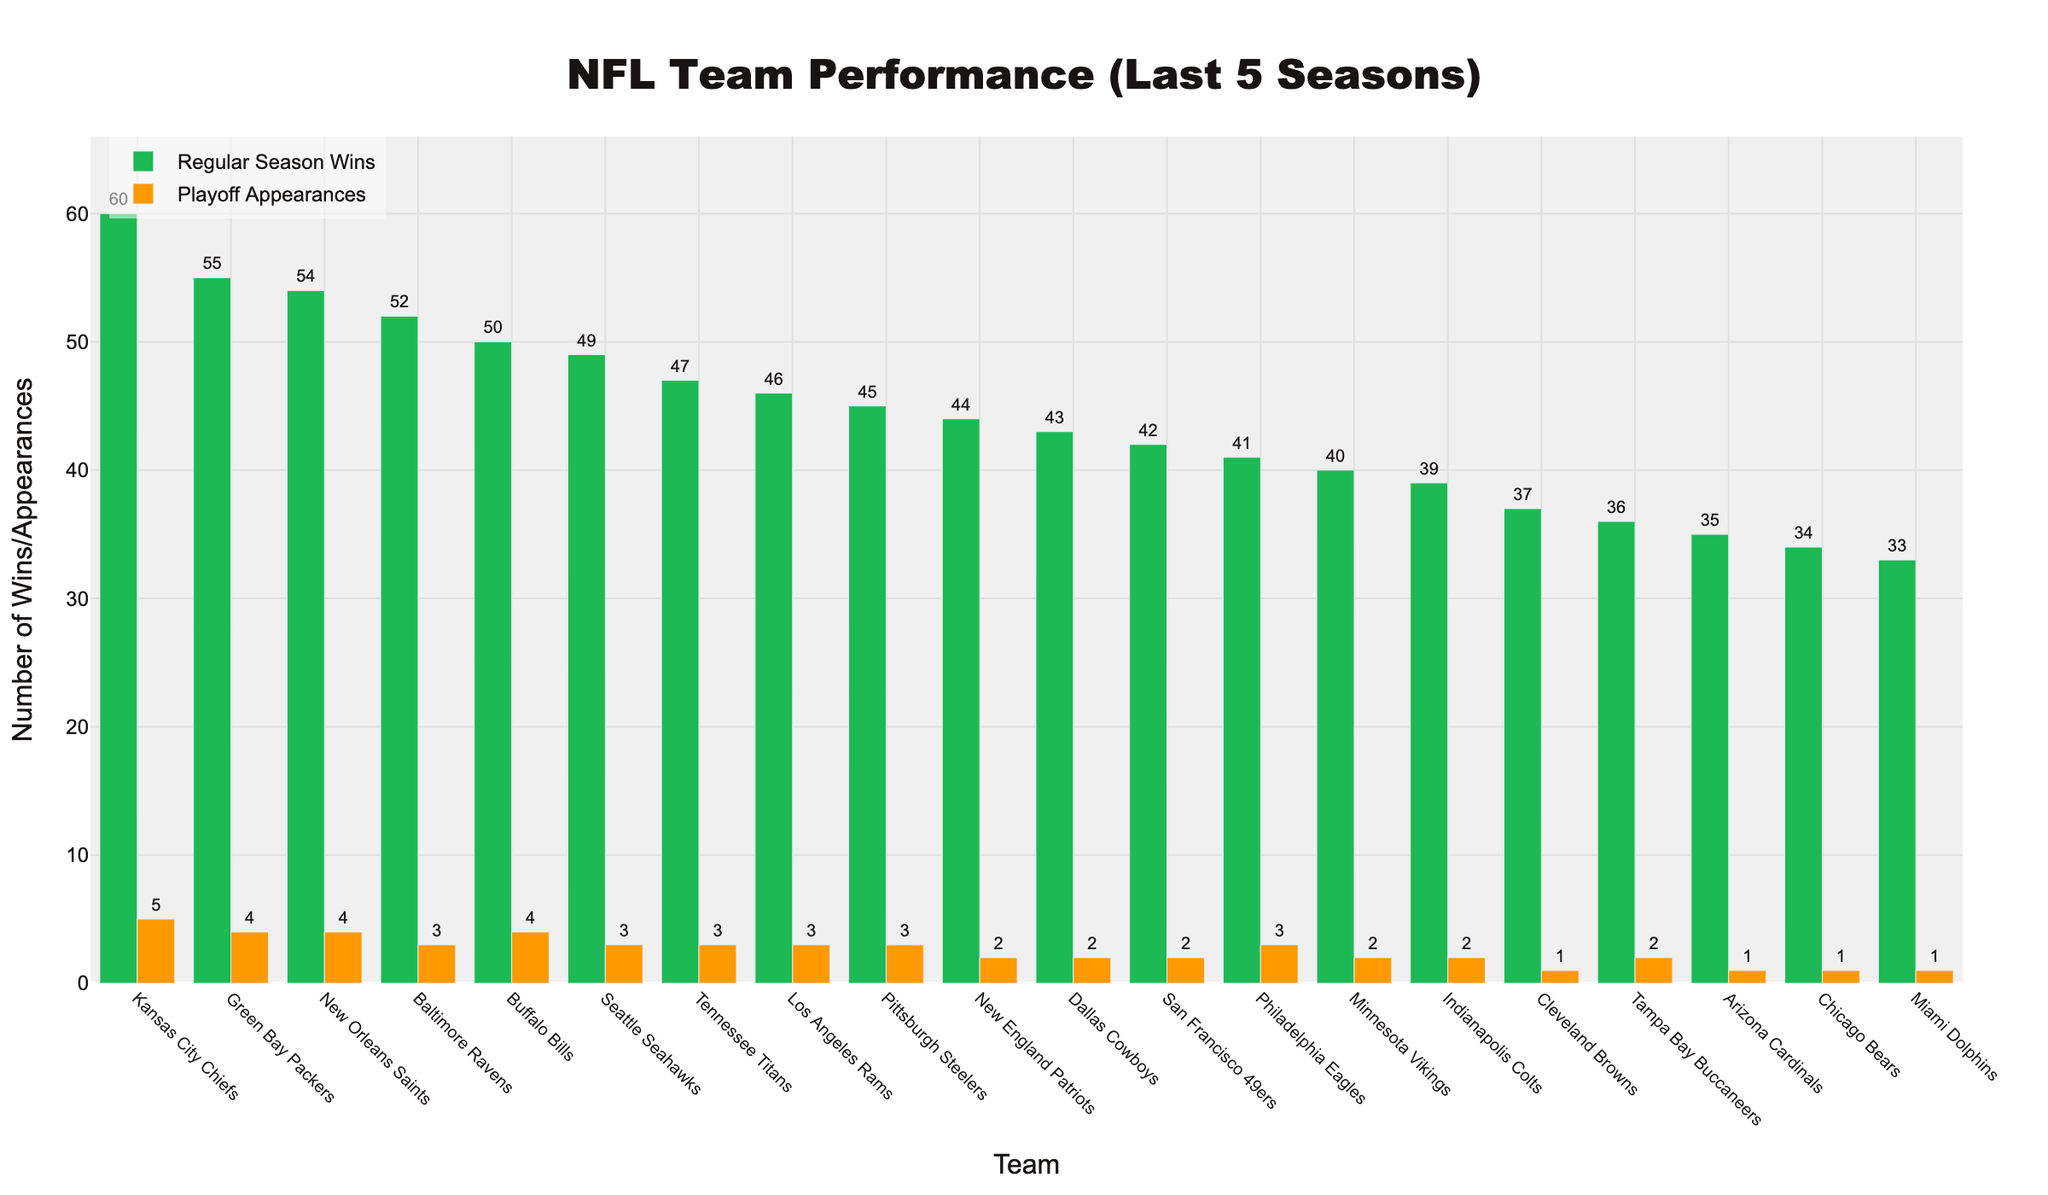Which team has the highest number of regular season wins? The bar representing the Kansas City Chiefs is the tallest for regular season wins, indicating they have the highest number among all teams.
Answer: Kansas City Chiefs Which team has the most playoff appearances alongside the Kansas City Chiefs? Both Kansas City Chiefs and Buffalo Bills have a bar representing playoff appearances of 4, the highest among all teams.
Answer: Buffalo Bills Comparing the Green Bay Packers and the New Orleans Saints, which team has more playoff appearances? The bars representing playoff appearances for both Green Bay Packers and New Orleans Saints stand at 4, showing they have an equal number of playoff appearances.
Answer: Equal Which team has exactly one playoff appearance over the last 5 seasons, despite their number of regular season wins? Teams with a bar of height 1 for playoff appearances are the Cleveland Browns, Arizona Cardinals, Chicago Bears, and Miami Dolphins.
Answer: Cleveland Browns, Arizona Cardinals, Chicago Bears, Miami Dolphins How many more regular season wins do the Baltimore Ravens have compared to the Miami Dolphins? The Baltimore Ravens have a bar height of 52 for regular season wins, while the Miami Dolphins have a bar height of 33. The difference is 52 - 33 = 19.
Answer: 19 Which team has a higher regular season wins-to-playoff appearances ratio: Los Angeles Rams or Tampa Bay Buccaneers? Los Angeles Rams: 46 wins / 3 appearances = 15.33. Tampa Bay Buccaneers: 36 wins / 2 appearances = 18. The ratio is higher for Tampa Bay Buccaneers.
Answer: Tampa Bay Buccaneers What is the difference in total playoff appearances between teams that have won 50 or more regular season games and those that have won fewer? Teams with 50 or more wins (Kansas City Chiefs, Green Bay Packers, New Orleans Saints, Baltimore Ravens, Buffalo Bills) have appearances totaling 5 + 4 + 4 + 3 + 4 = 20. Teams with fewer than 50 wins have (3 + 3 + 3 + 2 + 2 + 2 + 3 + 2 + 2 + 1 + 1 + 1 + 1) = 24. Difference is 24 - 20 = 4.
Answer: 4 Which teams have an equal number of regular season wins and playoff appearances, and what are those numbers? No teams have bars of equal height for both regular season wins and playoff appearances.
Answer: None 